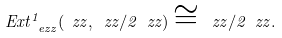<formula> <loc_0><loc_0><loc_500><loc_500>E x t _ { \ e z z } ^ { 1 } ( \ z z , \ z z / 2 \ z z ) \cong \ z z / 2 \ z z .</formula> 